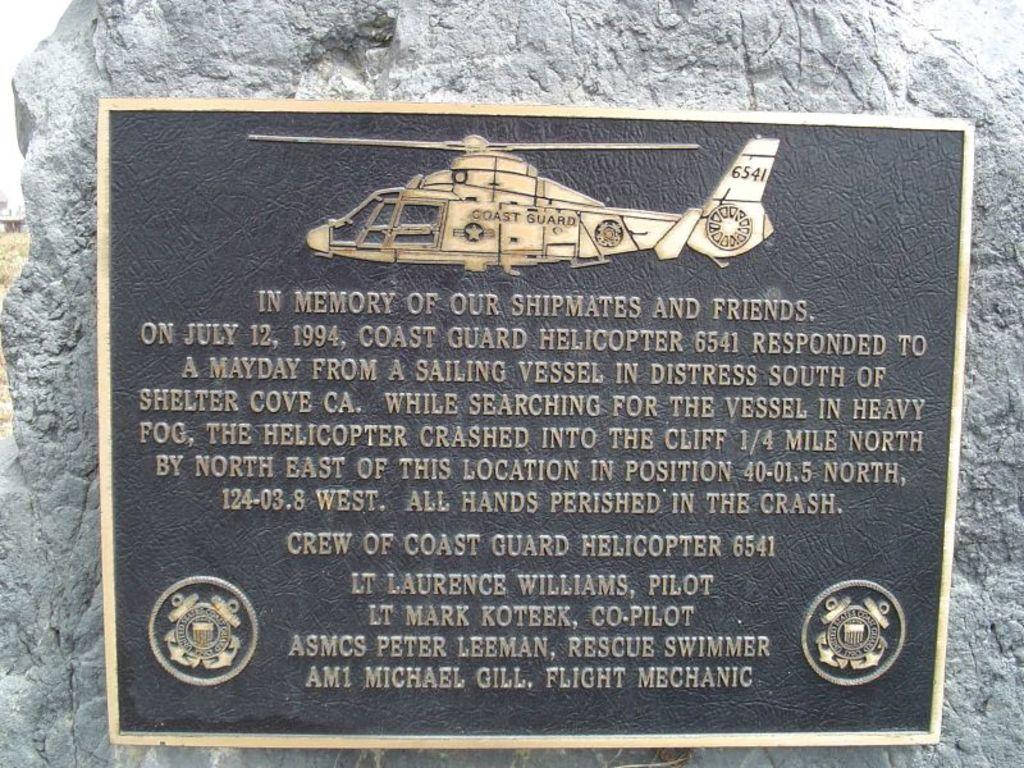<image>
Render a clear and concise summary of the photo. A plaque in memory of those killed when a coast guard helicopter crashed is hung on a stone. 